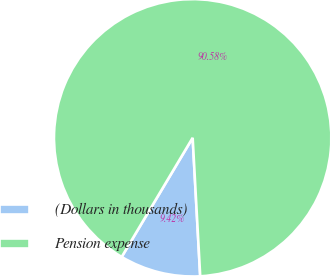<chart> <loc_0><loc_0><loc_500><loc_500><pie_chart><fcel>(Dollars in thousands)<fcel>Pension expense<nl><fcel>9.42%<fcel>90.58%<nl></chart> 